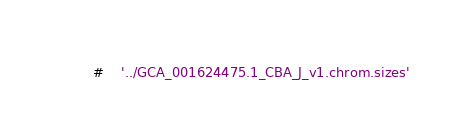Convert code to text. <code><loc_0><loc_0><loc_500><loc_500><_SQL_>#	'../GCA_001624475.1_CBA_J_v1.chrom.sizes'
</code> 